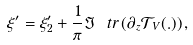Convert formula to latex. <formula><loc_0><loc_0><loc_500><loc_500>\xi ^ { \prime } = \xi ^ { \prime } _ { 2 } + \frac { 1 } { \pi } \Im \ t r \left ( \partial _ { z } { \mathcal { T } } _ { V } ( . ) \right ) ,</formula> 